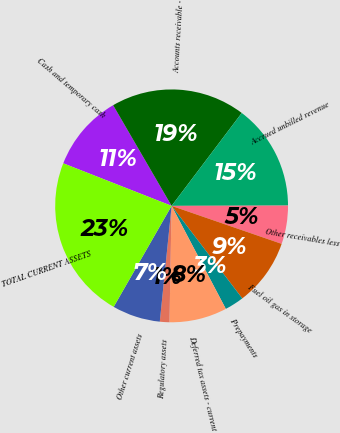Convert chart. <chart><loc_0><loc_0><loc_500><loc_500><pie_chart><fcel>Cash and temporary cash<fcel>Accounts receivable -<fcel>Accrued unbilled revenue<fcel>Other receivables less<fcel>Fuel oil gas in storage<fcel>Prepayments<fcel>Deferred tax assets - current<fcel>Regulatory assets<fcel>Other current assets<fcel>TOTAL CURRENT ASSETS<nl><fcel>10.67%<fcel>18.67%<fcel>14.67%<fcel>5.33%<fcel>9.33%<fcel>2.67%<fcel>8.0%<fcel>1.33%<fcel>6.67%<fcel>22.67%<nl></chart> 